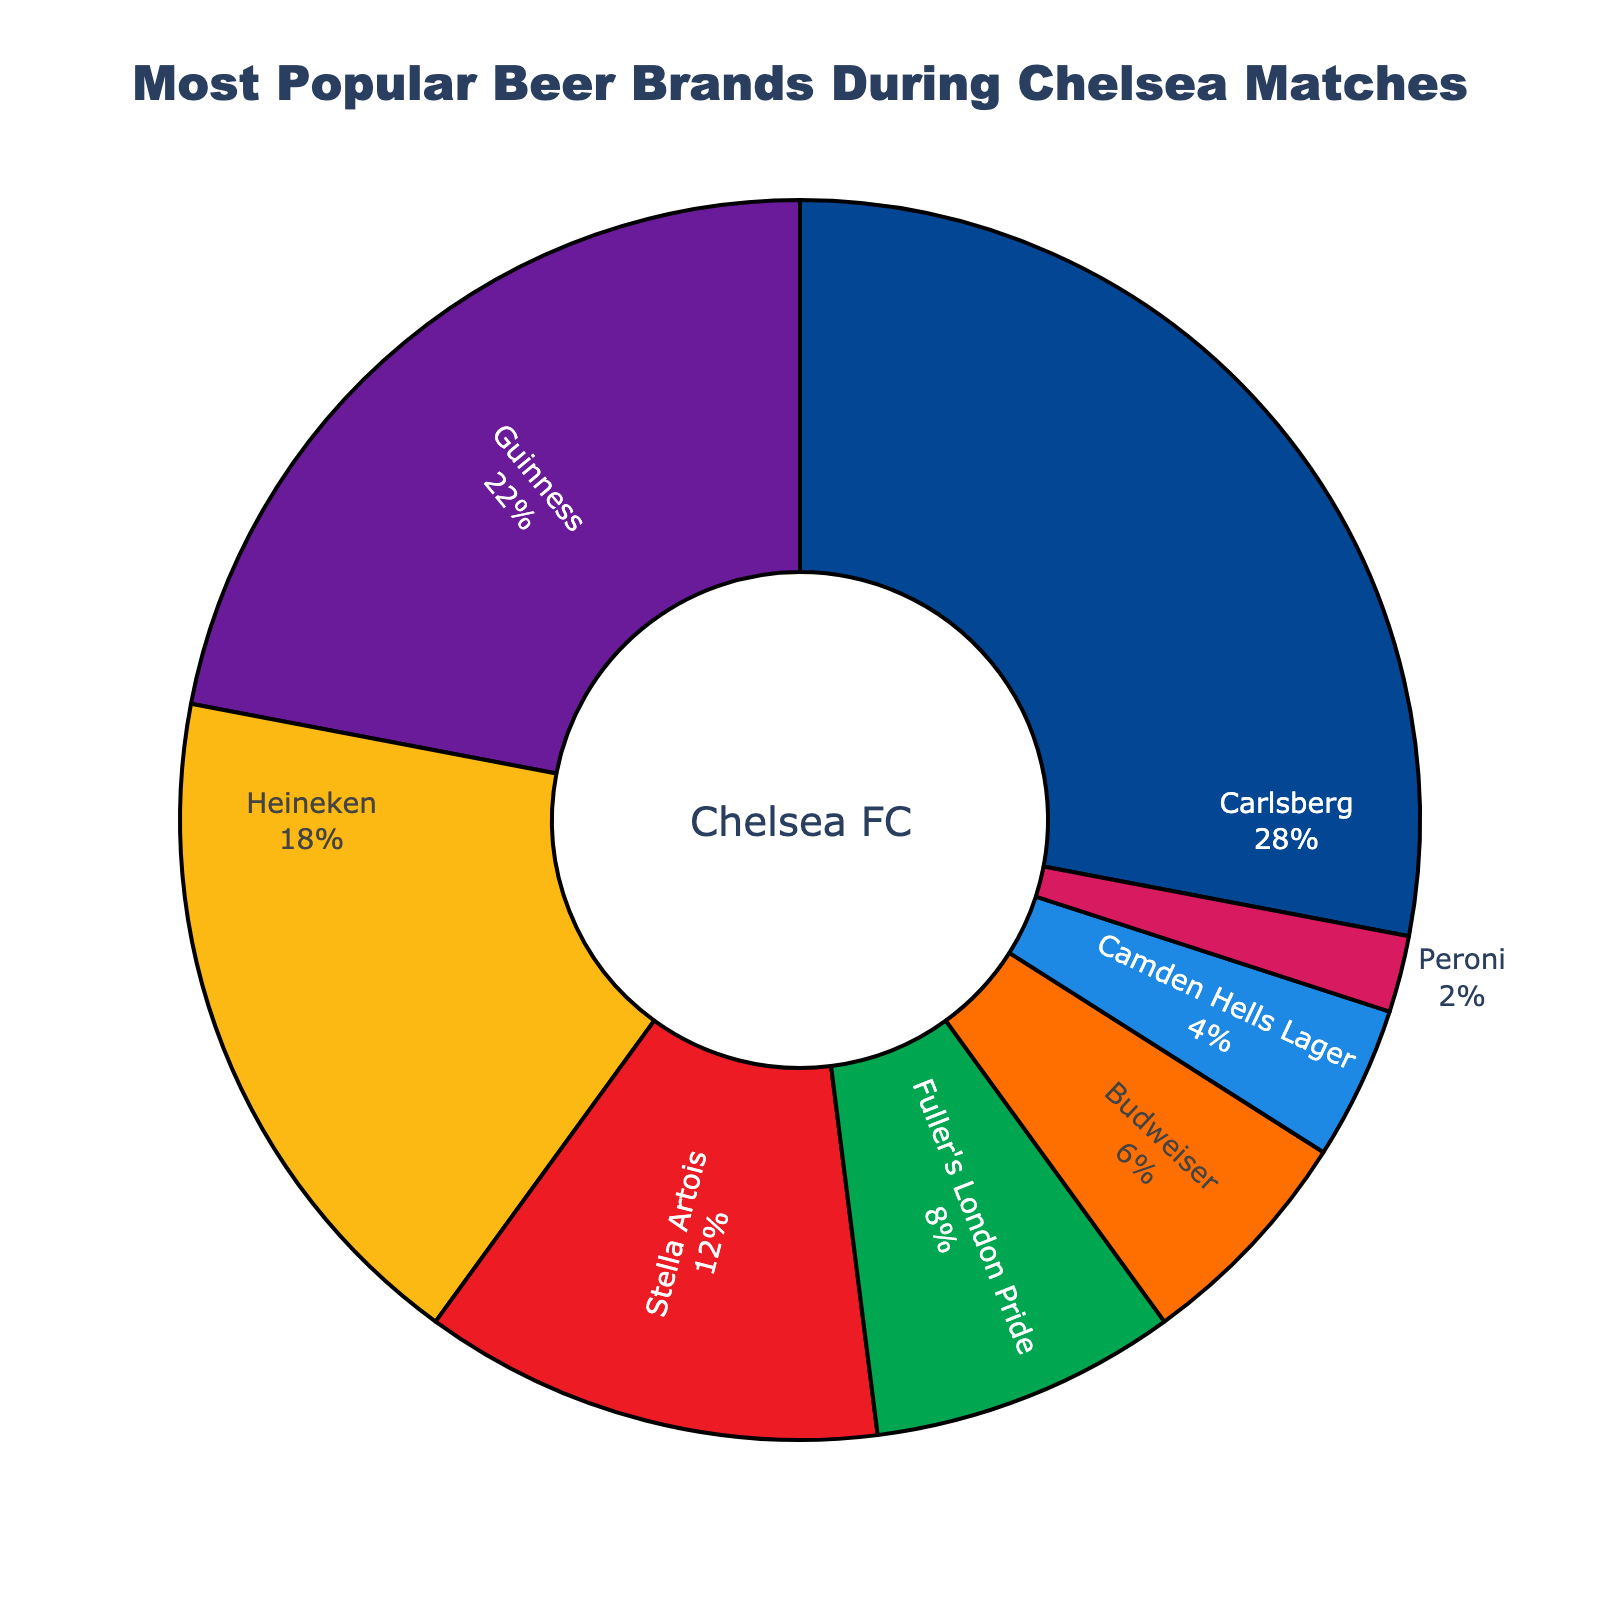What's the most popular beer brand sold during Chelsea matches? According to the pie chart, the brand with the highest percentage is the most popular.
Answer: Carlsberg Which beer brand accounts for the smallest segment of the chart? The smallest segment in the pie chart corresponds to the brand with the lowest percentage.
Answer: Peroni How much more popular is Carlsberg compared to Camden Hells Lager? Carlsberg has 28% while Camden Hells Lager has 4%. Subtracting 4% from 28% gives the difference.
Answer: 24% If you combine the percentages of Guinness and Heineken, what is the total percentage? Add the percentages of Guinness (22%) and Heineken (18%) together.
Answer: 40% What color represents Stella Artois on the chart? Stella Artois is depicted in red on the chart as indicated by visual inspection.
Answer: Red Is Guinness more popular than Stella Artois and Fuller's London Pride combined? The combined percentage of Stella Artois (12%) and Fuller's London Pride (8%) is 20%. Since Guinness is 22%, it is indeed more popular.
Answer: Yes Between Heineken and Budweiser, which has a higher percentage? By comparing the respective percentages, Heineken with 18% is higher than Budweiser with 6%.
Answer: Heineken What is the average popularity percentage of the three least popular beers? Add percentages of the least popular beers: Budweiser (6%), Camden Hells Lager (4%), and Peroni (2%) and divide by 3. (6 + 4 + 2) / 3 = 12 / 3.
Answer: 4% Which beer brands individually account for more than 10% of total sales? Brands that have percentages greater than 10% are identified as Carlsberg (28%), Guinness (22%), Heineken (18%), and Stella Artois (12%).
Answer: Carlsberg, Guinness, Heineken, Stella Artois Among Carlsberg, Fuller's London Pride, and Peroni, which one has the median percentage? Sorting the percentages: Carlsberg (28%), Fuller's London Pride (8%), and Peroni (2%), the median value, or middle one, is the second-highest.
Answer: Fuller's London Pride 